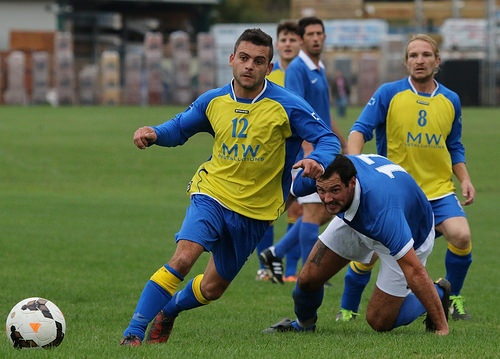<image>
Is the man behind the man? Yes. From this viewpoint, the man is positioned behind the man, with the man partially or fully occluding the man. 